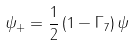Convert formula to latex. <formula><loc_0><loc_0><loc_500><loc_500>\psi _ { + } = \frac { 1 } { 2 } \left ( 1 - \Gamma _ { 7 } \right ) \psi</formula> 